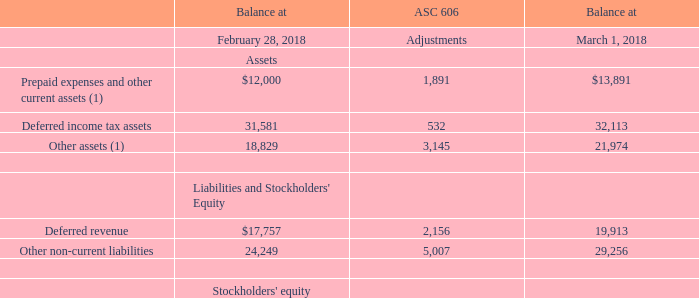As a result of the adoption of ASC 606, our deferred product revenues and deferred product costs for the fleet management and auto vehicle finance verticals increased as balances are now amortized over the estimated average in-service lives of these devices. Deferred income tax assets and accumulated deficit increased as a result of the changes made to our deferred product revenues and deferred product costs. The cumulative effect of the changes made to our consolidated balance sheet for the adoption of ASC 606 were as follows (in thousands):
(1) Deferred product costs included in Prepaid expenses and other current assets and Other assets amounted to $5.4 million and $6.0 million, respectively, as of March 1, 2018.
What were the results of the adoption of ASC 606 to the company? Deferred product revenues and deferred product costs for the fleet management and auto vehicle finance verticals increased. What was the balance of deferred income tax assets at February 28, 2018?
Answer scale should be: thousand. 31,581. What was the balance of deferred income tax assets at March 1,2018?
Answer scale should be: thousand. 32,113. What were the balance of total assets at February 28, 2018?
Answer scale should be: thousand. (12,000+31,581+18,829)
Answer: 62410. What were the balance of total assets at March 1, 2018?
Answer scale should be: thousand. (13,891+32,113+21,974)
Answer: 67978. What is the difference in balance of Deferred income tax assets and Deferred revenue at February 28, 2018?
Answer scale should be: thousand. (31,581-17,757)
Answer: 13824. 